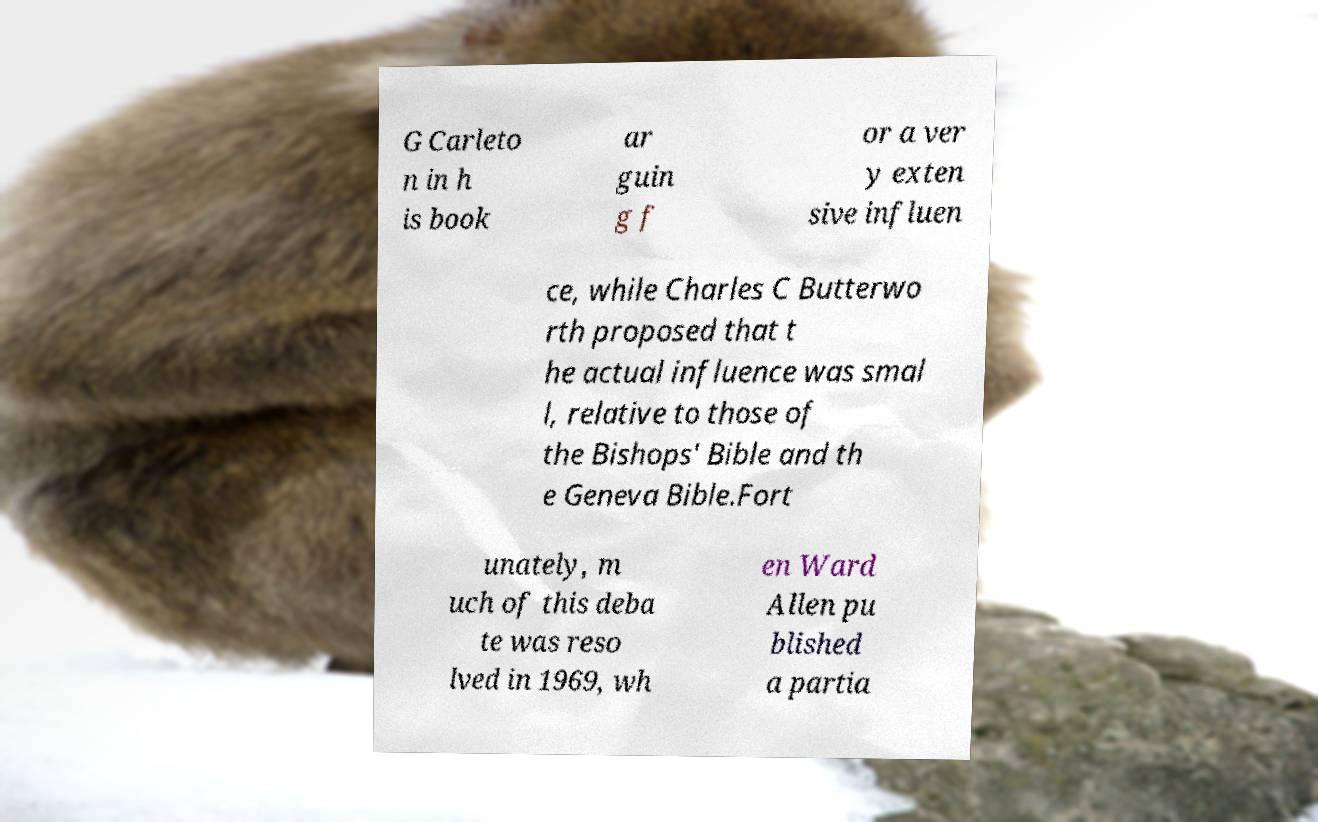Can you read and provide the text displayed in the image?This photo seems to have some interesting text. Can you extract and type it out for me? G Carleto n in h is book ar guin g f or a ver y exten sive influen ce, while Charles C Butterwo rth proposed that t he actual influence was smal l, relative to those of the Bishops' Bible and th e Geneva Bible.Fort unately, m uch of this deba te was reso lved in 1969, wh en Ward Allen pu blished a partia 